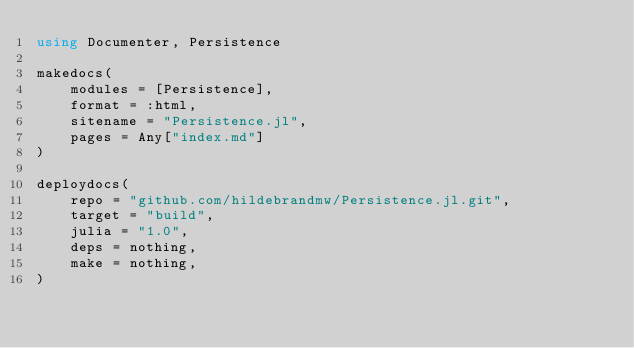Convert code to text. <code><loc_0><loc_0><loc_500><loc_500><_Julia_>using Documenter, Persistence

makedocs(
    modules = [Persistence],
    format = :html,
    sitename = "Persistence.jl",
    pages = Any["index.md"]
)

deploydocs(
    repo = "github.com/hildebrandmw/Persistence.jl.git",
    target = "build",
    julia = "1.0",
    deps = nothing,
    make = nothing,
)
</code> 